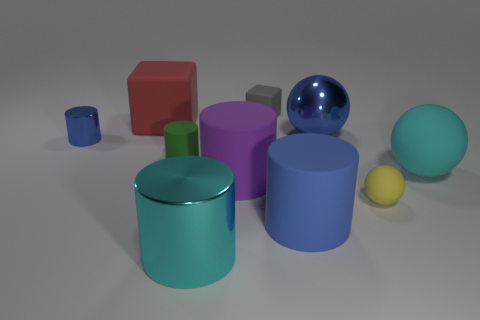Subtract all large blue rubber cylinders. How many cylinders are left? 4 Subtract all purple cylinders. How many cylinders are left? 4 Subtract all yellow cylinders. Subtract all brown spheres. How many cylinders are left? 5 Subtract all balls. How many objects are left? 7 Add 4 small green cylinders. How many small green cylinders exist? 5 Subtract 0 gray balls. How many objects are left? 10 Subtract all green things. Subtract all small blue metal cylinders. How many objects are left? 8 Add 3 big red matte objects. How many big red matte objects are left? 4 